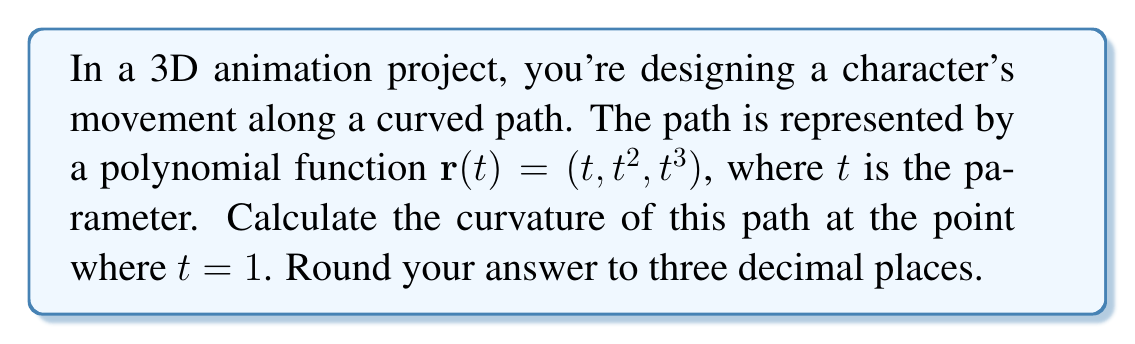Provide a solution to this math problem. To calculate the curvature of a 3D path, we'll use the formula:

$$\kappa = \frac{|\mathbf{r}'(t) \times \mathbf{r}''(t)|}{|\mathbf{r}'(t)|^3}$$

Where $\mathbf{r}'(t)$ is the first derivative and $\mathbf{r}''(t)$ is the second derivative of the position vector.

Step 1: Calculate $\mathbf{r}'(t)$
$$\mathbf{r}'(t) = (1, 2t, 3t^2)$$

Step 2: Calculate $\mathbf{r}''(t)$
$$\mathbf{r}''(t) = (0, 2, 6t)$$

Step 3: Evaluate $\mathbf{r}'(t)$ and $\mathbf{r}''(t)$ at $t = 1$
$$\mathbf{r}'(1) = (1, 2, 3)$$
$$\mathbf{r}''(1) = (0, 2, 6)$$

Step 4: Calculate the cross product $\mathbf{r}'(1) \times \mathbf{r}''(1)$
$$\mathbf{r}'(1) \times \mathbf{r}''(1) = (2 \cdot 6 - 3 \cdot 2, 3 \cdot 0 - 1 \cdot 6, 1 \cdot 2 - 2 \cdot 0) = (6, -6, 2)$$

Step 5: Calculate $|\mathbf{r}'(1) \times \mathbf{r}''(1)|$
$$|\mathbf{r}'(1) \times \mathbf{r}''(1)| = \sqrt{6^2 + (-6)^2 + 2^2} = \sqrt{76}$$

Step 6: Calculate $|\mathbf{r}'(1)|^3$
$$|\mathbf{r}'(1)|^3 = (|\mathbf{r}'(1)|)^3 = (\sqrt{1^2 + 2^2 + 3^2})^3 = (\sqrt{14})^3 = 14\sqrt{14}$$

Step 7: Apply the curvature formula
$$\kappa = \frac{|\mathbf{r}'(1) \times \mathbf{r}''(1)|}{|\mathbf{r}'(1)|^3} = \frac{\sqrt{76}}{14\sqrt{14}}$$

Step 8: Simplify and round to three decimal places
$$\kappa \approx 0.321$$
Answer: $0.321$ 